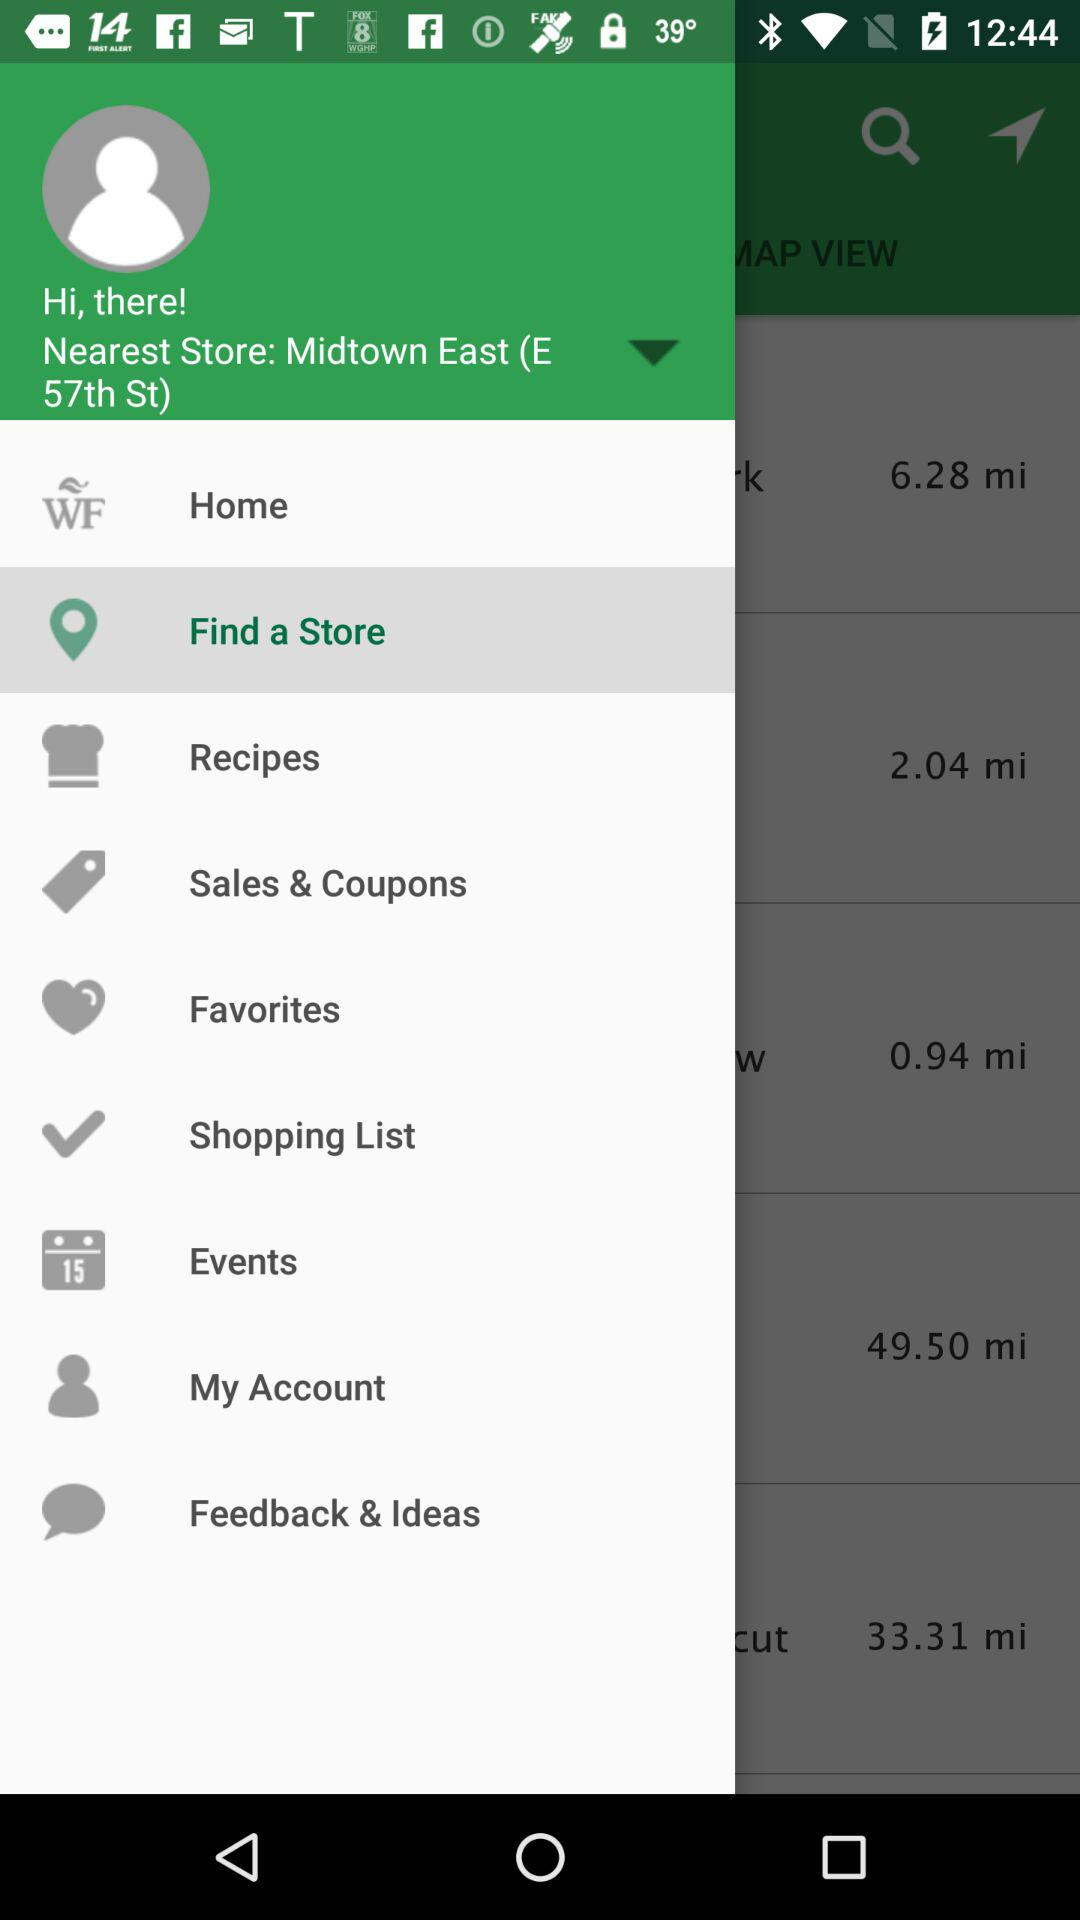What is the location of the store? The location of the store is Midtown East (E 57th St). 